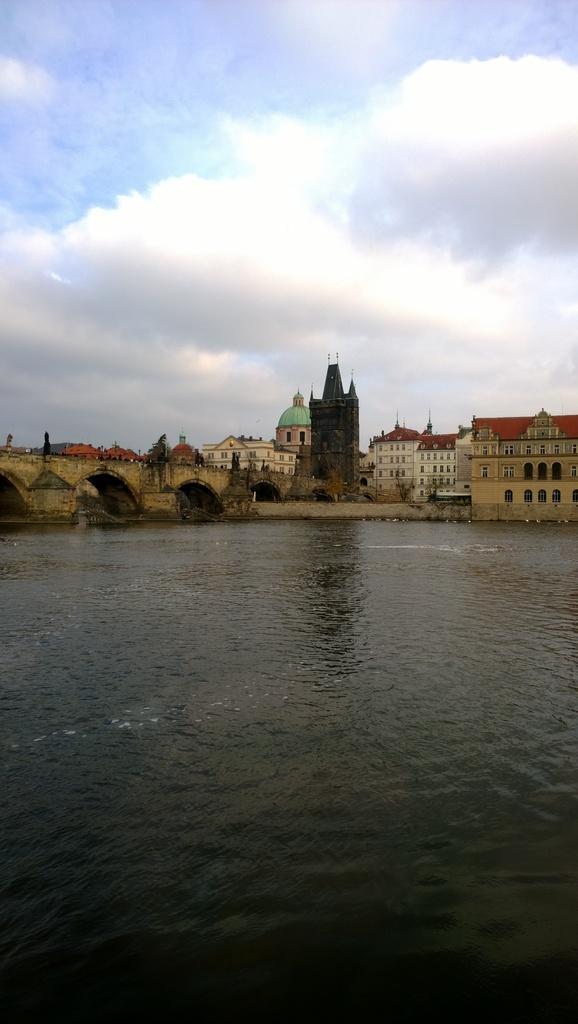Could you give a brief overview of what you see in this image? In the picture we can see the water surface and far away from it, we can see some tunnel ways and beside it, we can see some buildings and behind it we can see the sky with clouds. 